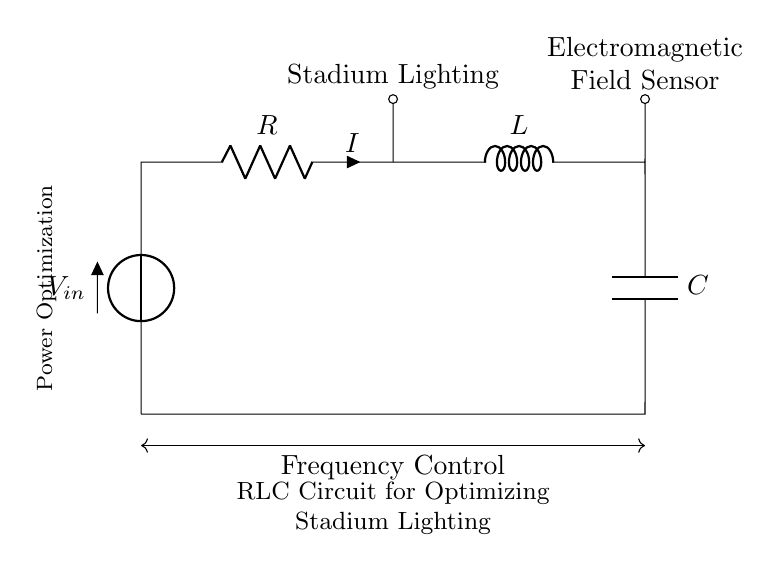What components are used in the circuit? The circuit includes three main components: a resistor, an inductor, and a capacitor, which are connected in series.
Answer: Resistor, Inductor, Capacitor What does the Voltage source represent in this circuit? The Voltage source represents the input voltage needed to drive the current through the RLC circuit, powering the stadium lighting system.
Answer: Input voltage What does the current direction indicate? The current direction flows from the positive side of the voltage source, through the resistor, inductor, and capacitor, showing the path of electric flow needed for the lighting system.
Answer: Flow direction What is the purpose of this RLC circuit? The purpose is to optimize the power and performance of the stadium lighting system by managing the electromagnetic field created by the circuit.
Answer: Power optimization How does frequency control affect the circuit? Frequency control adjusts the responsiveness of the RLC circuit to changes in voltage and current, allowing for efficient management of the stadium lighting and minimizing energy waste.
Answer: Efficiency management Which component is responsible for storing energy in the electromagnetic field? The inductor is responsible for storing energy in the electromagnetic field when current flows through it, affecting the time-dependent behavior of the circuit.
Answer: Inductor What is indicated by the electromagnetic field sensor in the circuit? The electromagnetic field sensor measures the strength and characteristics of the field created by the RLC circuit, helping to optimize lighting efficiency and performance.
Answer: Field measurement 